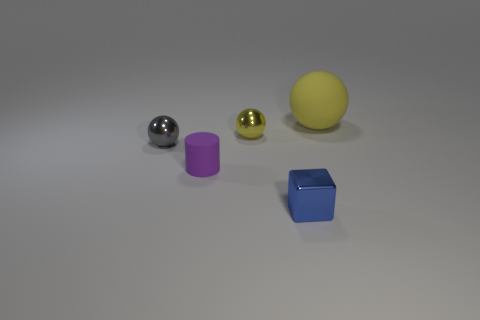There is a blue object; is its shape the same as the small object that is behind the tiny gray metallic ball?
Your answer should be very brief. No. There is a matte cylinder that is the same size as the cube; what is its color?
Provide a succinct answer. Purple. Are there fewer matte objects that are left of the tiny gray shiny sphere than tiny rubber things behind the cylinder?
Provide a short and direct response. No. There is a matte thing that is behind the tiny thing that is to the left of the matte thing that is in front of the large yellow ball; what shape is it?
Your response must be concise. Sphere. Does the small shiny sphere that is behind the tiny gray thing have the same color as the small metal thing on the left side of the small purple matte cylinder?
Your answer should be very brief. No. What shape is the other thing that is the same color as the big object?
Ensure brevity in your answer.  Sphere. What number of matte objects are yellow spheres or small blue spheres?
Keep it short and to the point. 1. What is the color of the matte object in front of the yellow thing that is behind the tiny thing behind the gray metal ball?
Your response must be concise. Purple. There is another metallic thing that is the same shape as the small yellow object; what color is it?
Offer a very short reply. Gray. Is there any other thing that has the same color as the large matte object?
Provide a succinct answer. Yes. 